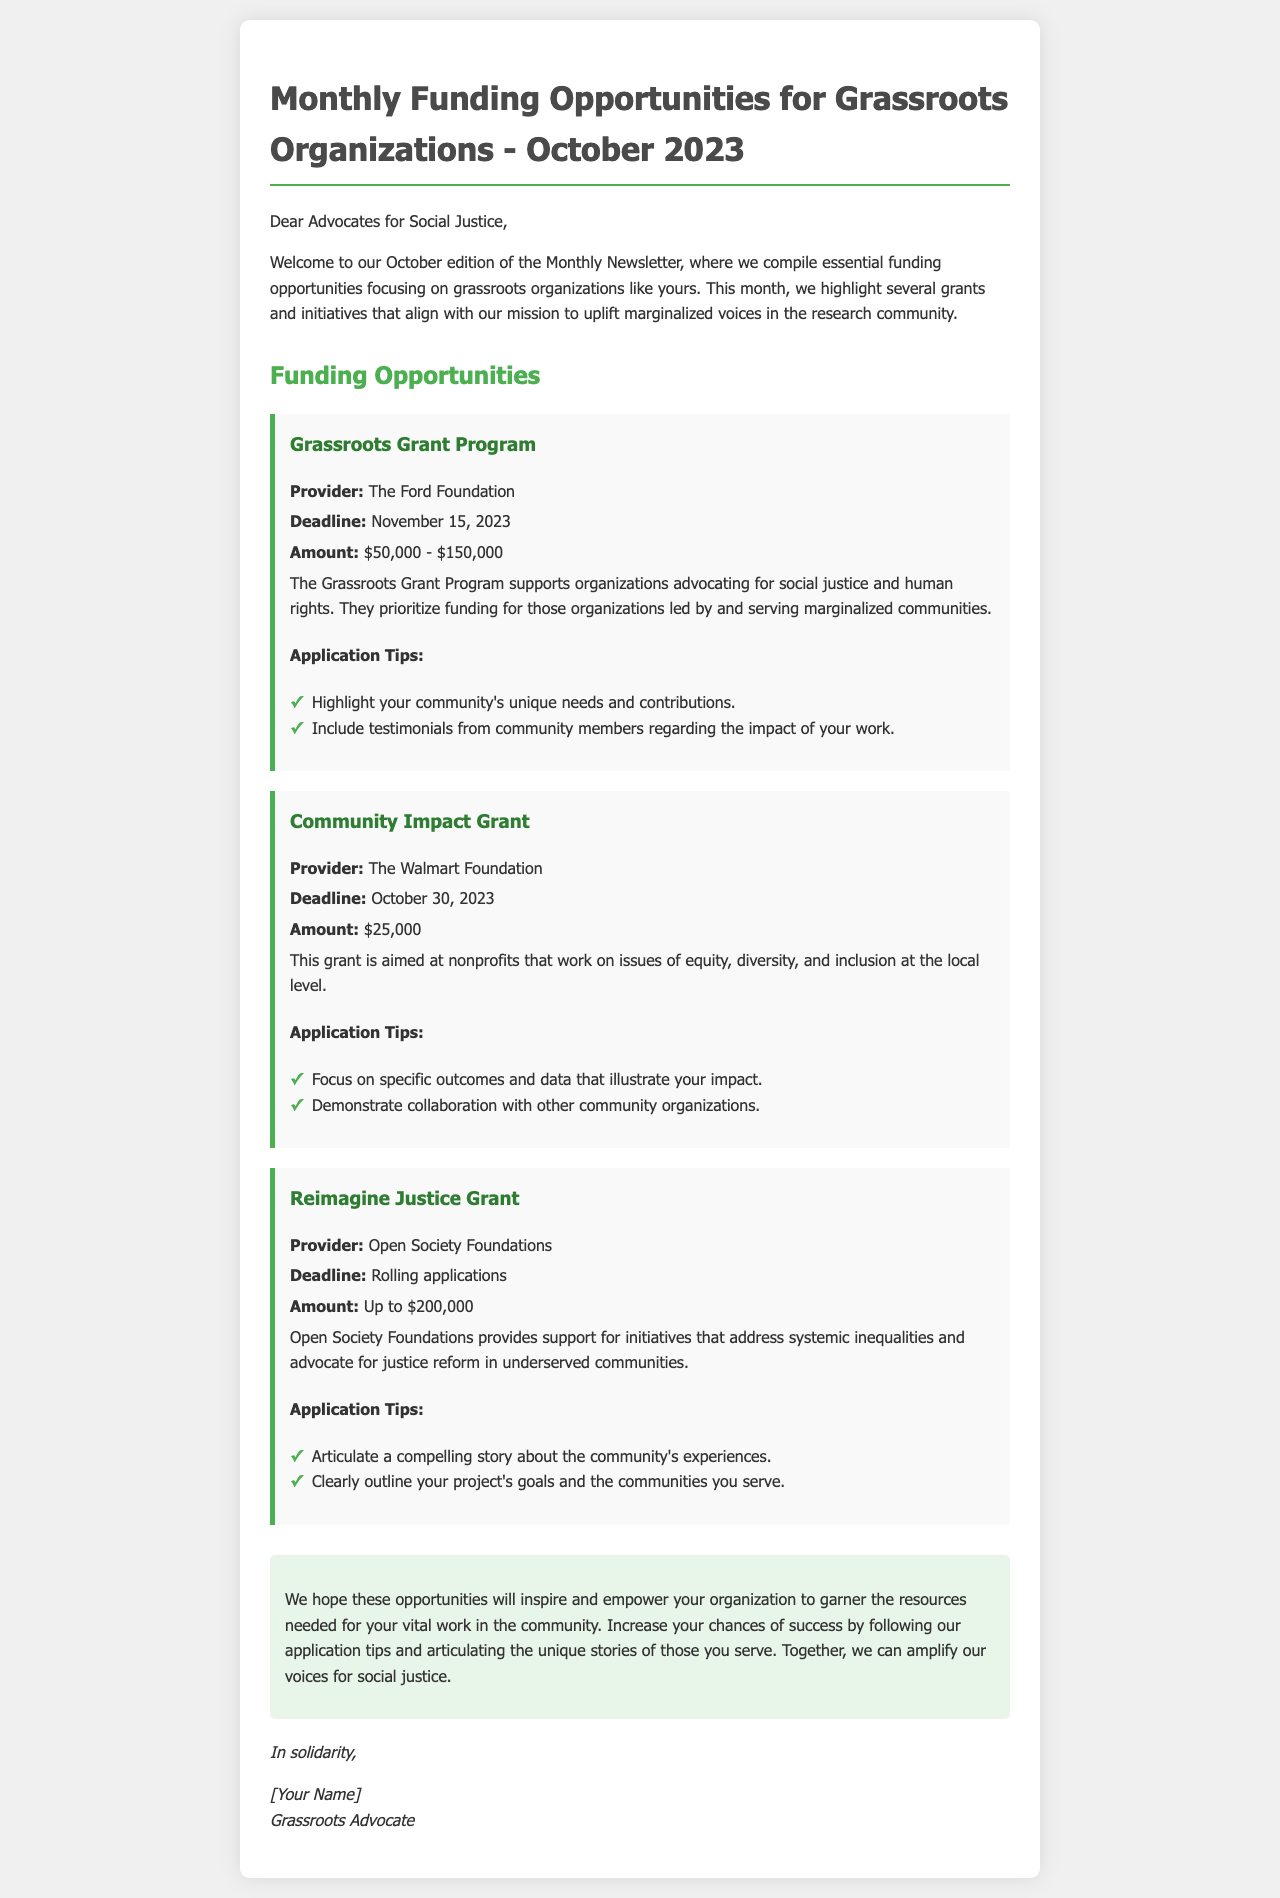What is the title of the newsletter? The title of the newsletter is indicated at the beginning of the document.
Answer: Monthly Funding Opportunities for Grassroots Organizations - October 2023 Who is the provider of the Grassroots Grant Program? The provider is mentioned under the funding opportunity section for the Grassroots Grant Program.
Answer: The Ford Foundation What is the deadline for the Community Impact Grant? The deadline is explicitly stated in the document under the relevant grant section.
Answer: October 30, 2023 What is the maximum amount for the Reimagine Justice Grant? The amount is specified in the details of the grant opportunity.
Answer: Up to $200,000 What type of organizations does the Grassroots Grant Program prioritize? The targeted recipients are mentioned in the description of the Grassroots Grant Program.
Answer: Organizations led by and serving marginalized communities How should applications for the Community Impact Grant demonstrate collaboration? The tips provided emphasize the importance of collaboration in applications.
Answer: Demonstrate collaboration with other community organizations What is the primary focus of the Open Society Foundations according to the newsletter? The focus is outlined in the summary of the Reimagine Justice Grant.
Answer: Address systemic inequalities and advocate for justice reform What is one suggested application tip for the Grassroots Grant Program? Specific tips for the application are listed under each grant opportunity.
Answer: Highlight your community's unique needs and contributions 